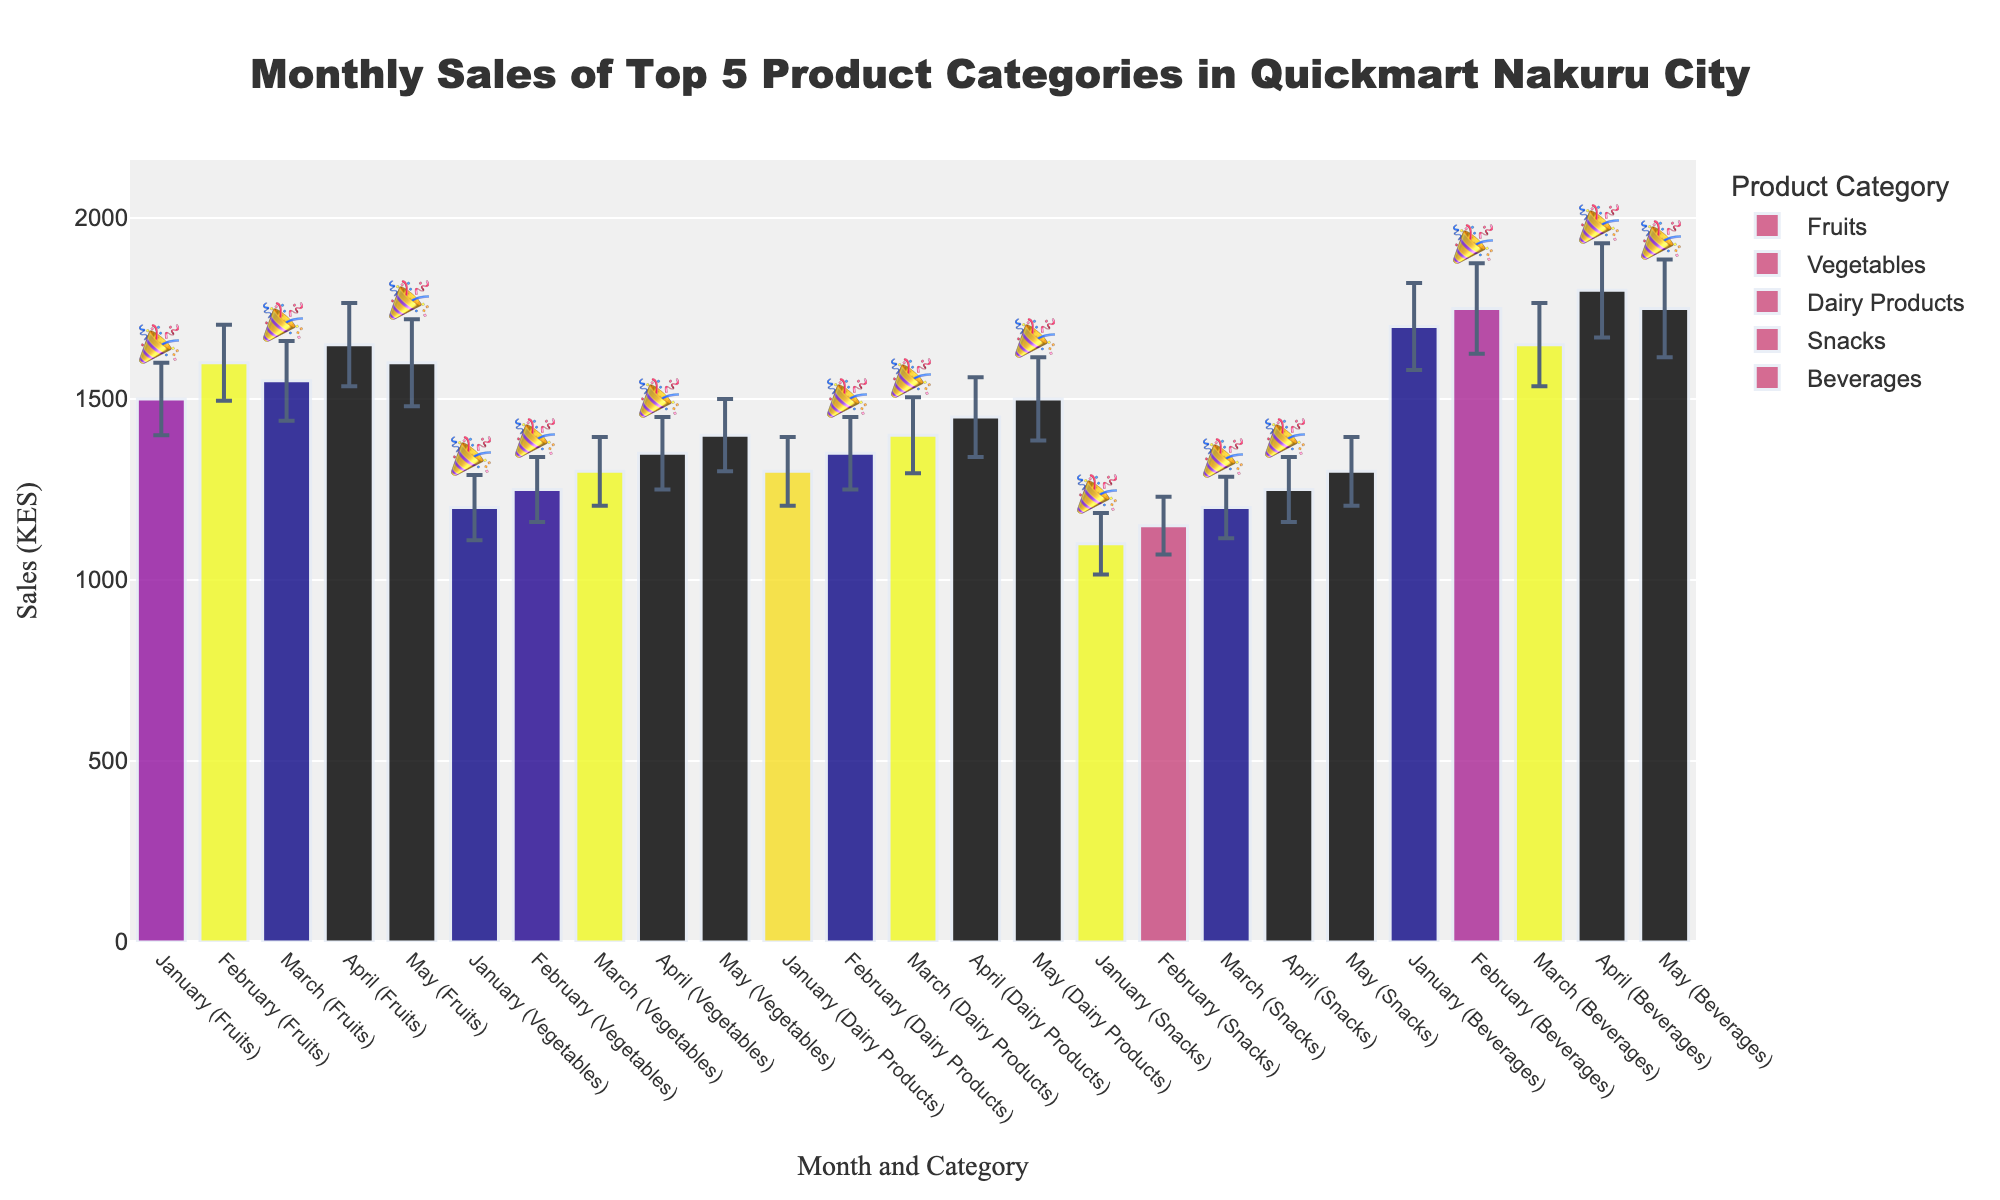Which category had the highest sales in January? By looking at the bars corresponding to January, we observe that Beverages had the highest sales among all categories.
Answer: Beverages What is the total sales for Fruits over the five months? Identify the sales values for Fruits in each month: January (1500), February (1600), March (1550), April (1650), and May (1600). Sum them up: 1500 + 1600 + 1550 + 1650 + 1600 = 7900.
Answer: 7900 Which category showed the most consistent sales according to the error bars? Consistent sales can be interpreted by smaller error bars. Vegetables have the smallest standard deviations across months, indicating more consistent sales.
Answer: Vegetables Did any category have a promotional campaign every month? Check the promotional campaign indicator (🎉) for each month across all categories. Vegetables and Snacks have the indicators in every month, denoting that they had a promotional campaign each month.
Answer: Vegetables, Snacks Compare the sales trend of Dairy Products and Snacks over the five months. Which one had higher sales overall? Summarize the sales for Dairy Products: January (1300), February (1350), March (1400), April (1450), May (1500). Then for Snacks: January (1100), February (1150), March (1200), April (1250), May (1300). Compare the totals: Dairy Products (1300+1350+1400+1450+1500 = 7000), Snacks (1100+1150+1200+1250+1300=6000).
Answer: Dairy Products What is the average sales value for Beverages across the five months? Identify and sum the sales values for Beverages across months: January (1700), February (1750), March (1650), April (1800), May (1750). Calculate the average: (1700 + 1750 + 1650 + 1800 + 1750) / 5 = 8650 / 5 = 1730.
Answer: 1730 Between January and May, in which month did Fruits have the lowest sales? Compare the sales values for Fruits from January (1500), February (1600), March (1550), April (1650), May (1600). The lowest sales occurred in January.
Answer: January How did promotional campaigns impact the sales of Vegetables in February and April? Compare sales in months with promotional campaigns and standard deviations for Vegetables. February had a sales value of 1250 with promotions and April had 1350 with promotions. Analyzing these, April showed higher sales than February.
Answer: April had higher sales Which month had the highest sales across all categories combined? Sum up the sales values across all categories for each month. January: 1500 + 1200 + 1300 + 1100 + 1700 = 6800, February: 1600 + 1250 + 1350 + 1150 + 1750 = 7100, March: 1550 + 1300 + 1400 + 1200 + 1650 = 7100, April: 1650 + 1350 + 1450 + 1250 + 1800 = 7500, May: 1600 + 1400 + 1500 + 1300 + 1750 = 7550. May had the highest combined sales.
Answer: May Is there any instance where the sales of Beverages decreased compared to the previous month? Analyze the sales of Beverages month by month: January (1700), February (1750), March (1650), April (1800), May (1750). Sales decreased from February to March.
Answer: Yes, February to March 